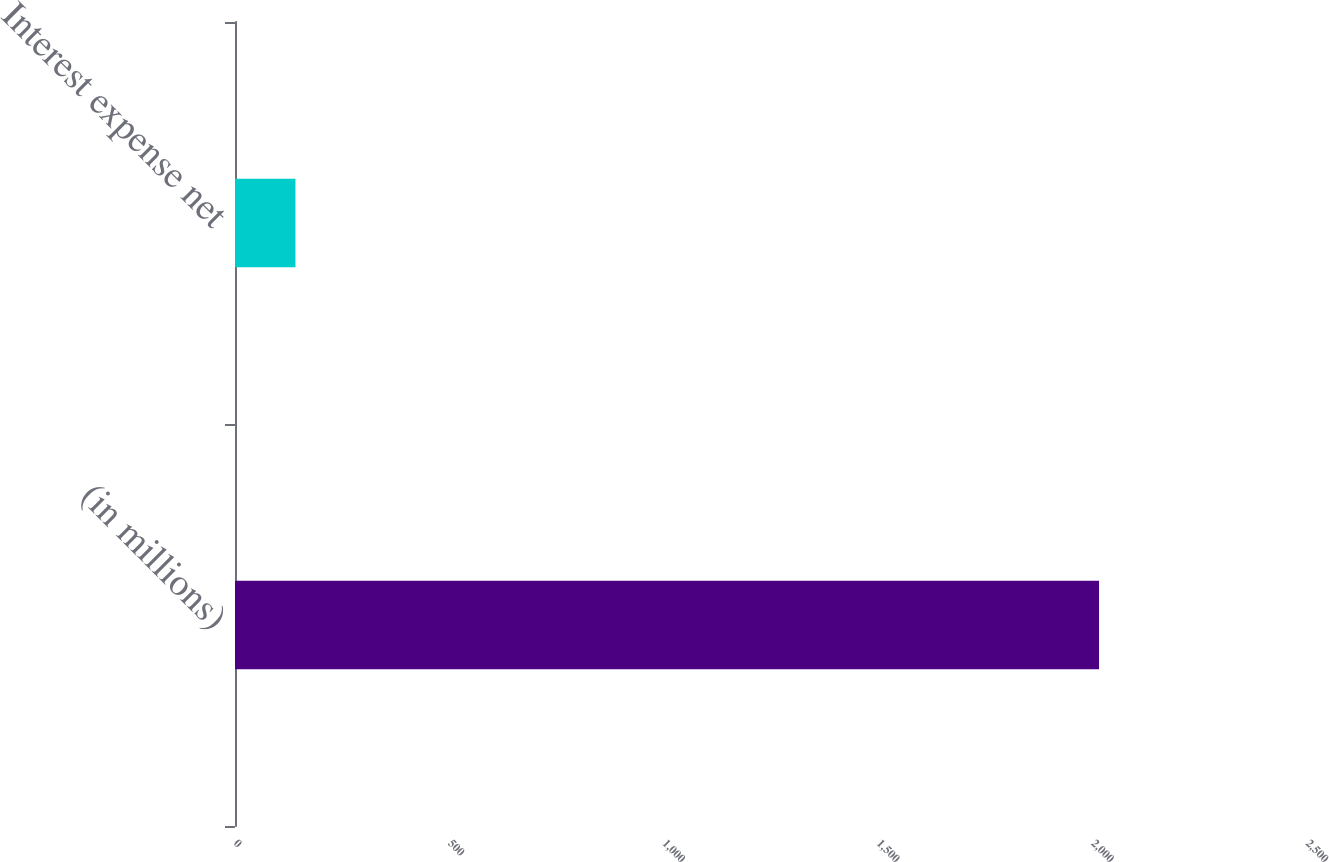Convert chart to OTSL. <chart><loc_0><loc_0><loc_500><loc_500><bar_chart><fcel>(in millions)<fcel>Interest expense net<nl><fcel>2015<fcel>141<nl></chart> 